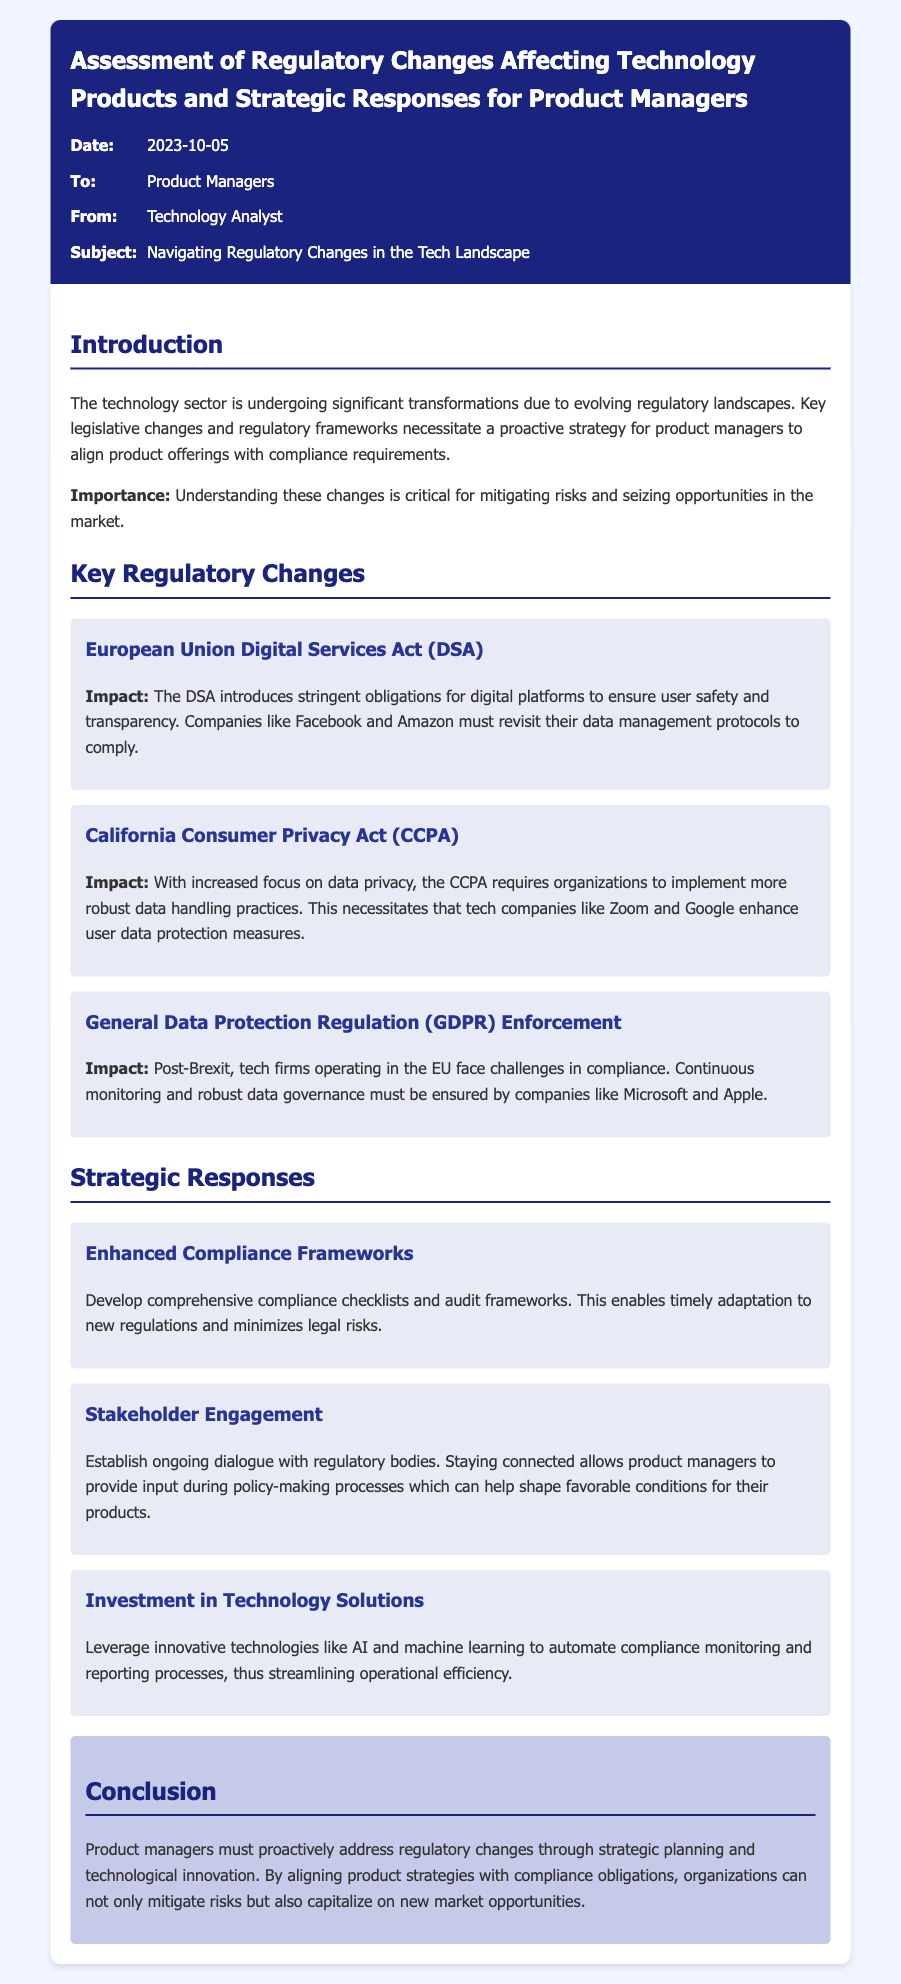what is the title of the memo? The title is located at the top of the document in the header section.
Answer: Assessment of Regulatory Changes Affecting Technology Products and Strategic Responses for Product Managers who is the memo addressed to? The recipient of the memo is mentioned in the meta-info section.
Answer: Product Managers when was the memo published? The publication date is detailed in the meta-info section of the memo.
Answer: 2023-10-05 what is one of the key regulatory changes mentioned? Key regulatory changes are listed in the document, requiring identification of one.
Answer: European Union Digital Services Act (DSA) what is a strategic response suggested for product managers? The document contains strategic responses to regulatory changes, which need to be summarized.
Answer: Enhanced Compliance Frameworks which company must comply with the California Consumer Privacy Act? The document provides examples of companies affected by the CCPA.
Answer: Zoom why is ongoing dialogue with regulatory bodies important? The reasoning for stakeholder engagement is explained as it aids in product managers' involvement in policy-making.
Answer: Helps shape favorable conditions for their products what should companies like Microsoft ensure post-Brexit? The memo mentions specific challenges for tech firms in the EU post-Brexit.
Answer: Continuous monitoring and robust data governance what is emphasized as critical for product managers in the conclusion? The conclusion outlines a key focus area for product managers regarding strategy.
Answer: Aligning product strategies with compliance obligations 